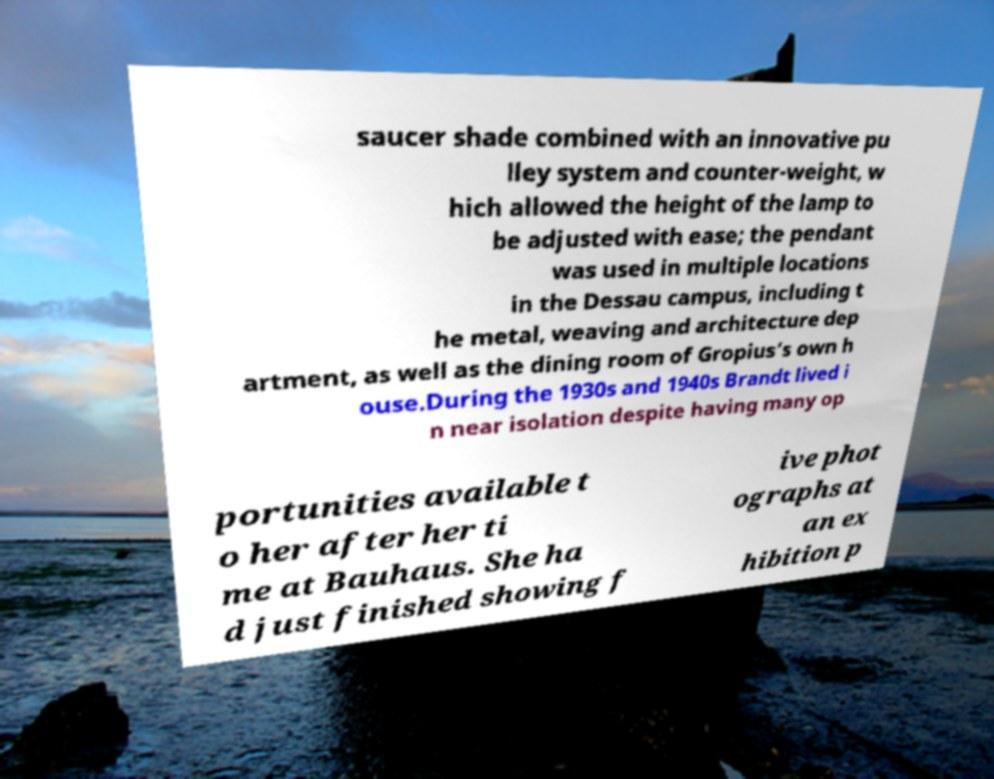I need the written content from this picture converted into text. Can you do that? saucer shade combined with an innovative pu lley system and counter-weight, w hich allowed the height of the lamp to be adjusted with ease; the pendant was used in multiple locations in the Dessau campus, including t he metal, weaving and architecture dep artment, as well as the dining room of Gropius’s own h ouse.During the 1930s and 1940s Brandt lived i n near isolation despite having many op portunities available t o her after her ti me at Bauhaus. She ha d just finished showing f ive phot ographs at an ex hibition p 